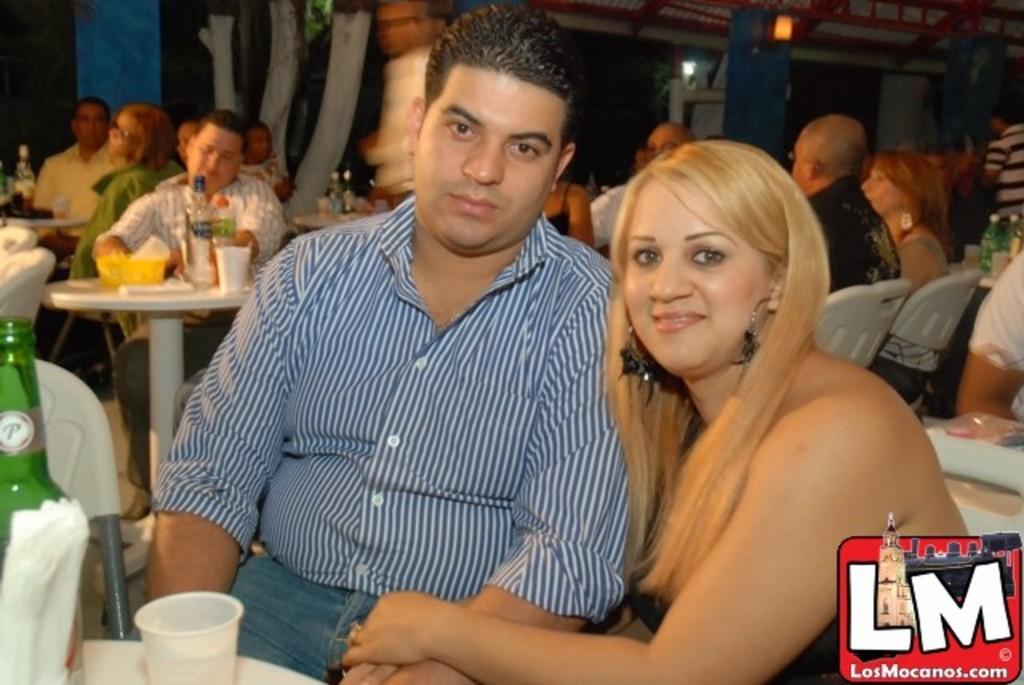Could you give a brief overview of what you see in this image? In the image we can see there are people who are sitting on chair and at the back there are lot of people who are sitting and on table there is water bottle and glass and a wine bottle. 